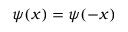<formula> <loc_0><loc_0><loc_500><loc_500>\psi ( x ) = \psi ( - x )</formula> 